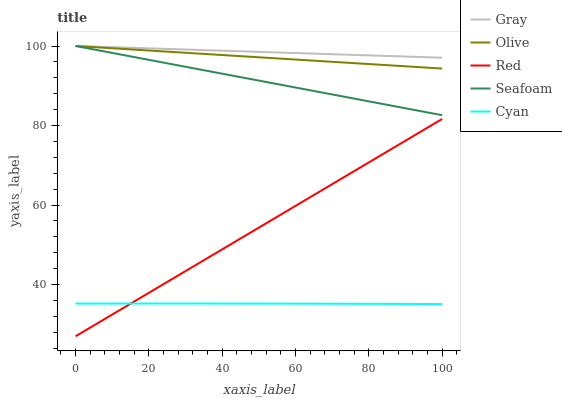Does Seafoam have the minimum area under the curve?
Answer yes or no. No. Does Seafoam have the maximum area under the curve?
Answer yes or no. No. Is Seafoam the smoothest?
Answer yes or no. No. Is Seafoam the roughest?
Answer yes or no. No. Does Seafoam have the lowest value?
Answer yes or no. No. Does Red have the highest value?
Answer yes or no. No. Is Cyan less than Gray?
Answer yes or no. Yes. Is Olive greater than Cyan?
Answer yes or no. Yes. Does Cyan intersect Gray?
Answer yes or no. No. 